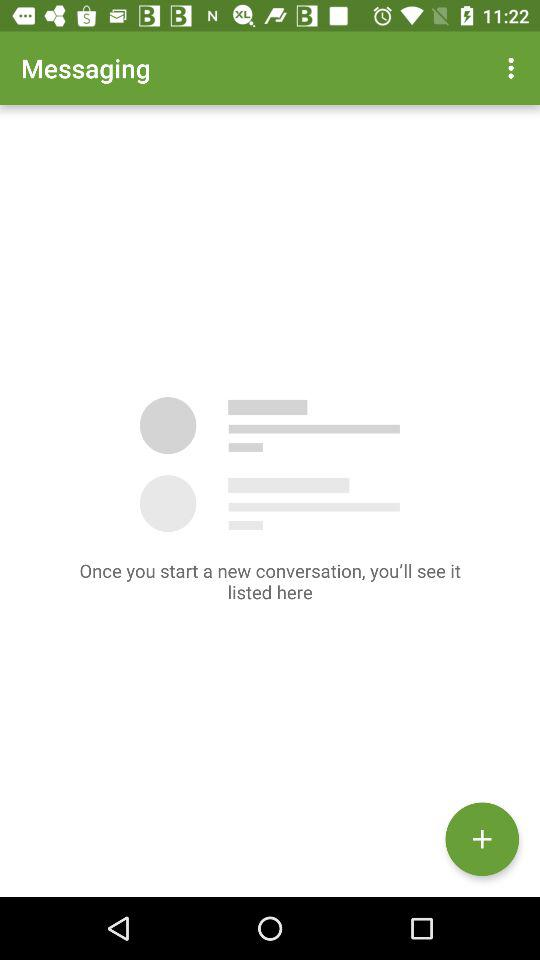What is the app name? The app name is "Messaging". 